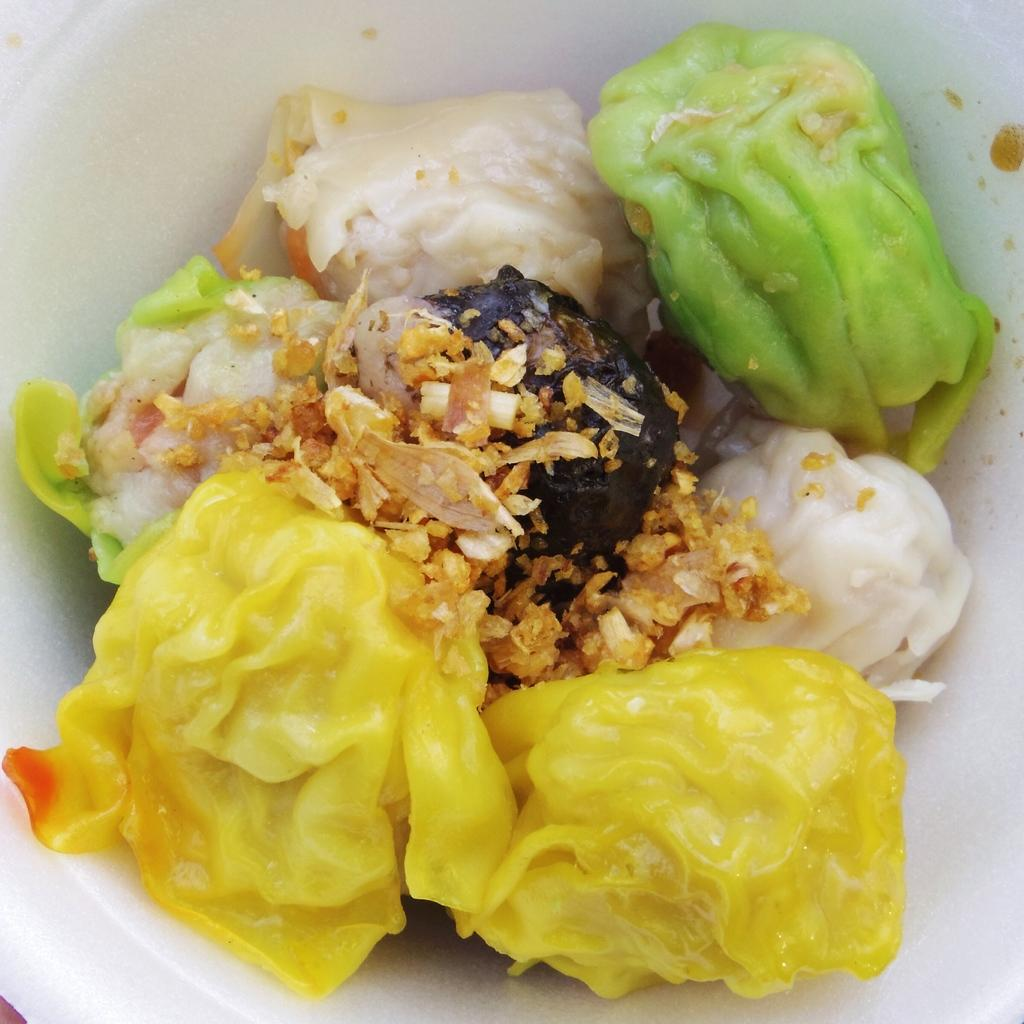What type of food is shown in the image? There are colorful yellow and green momo in the image. How are the momo arranged in the image? The momo are placed in a white bowl. What type of wax is being used for the educational purposes in the image? There is no wax or educational purpose present in the image; it features colorful momo in a white bowl. 